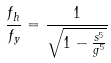<formula> <loc_0><loc_0><loc_500><loc_500>\frac { f _ { h } } { f _ { y } } = \frac { 1 } { \sqrt { 1 - \frac { s ^ { 5 } } { g ^ { 5 } } } }</formula> 